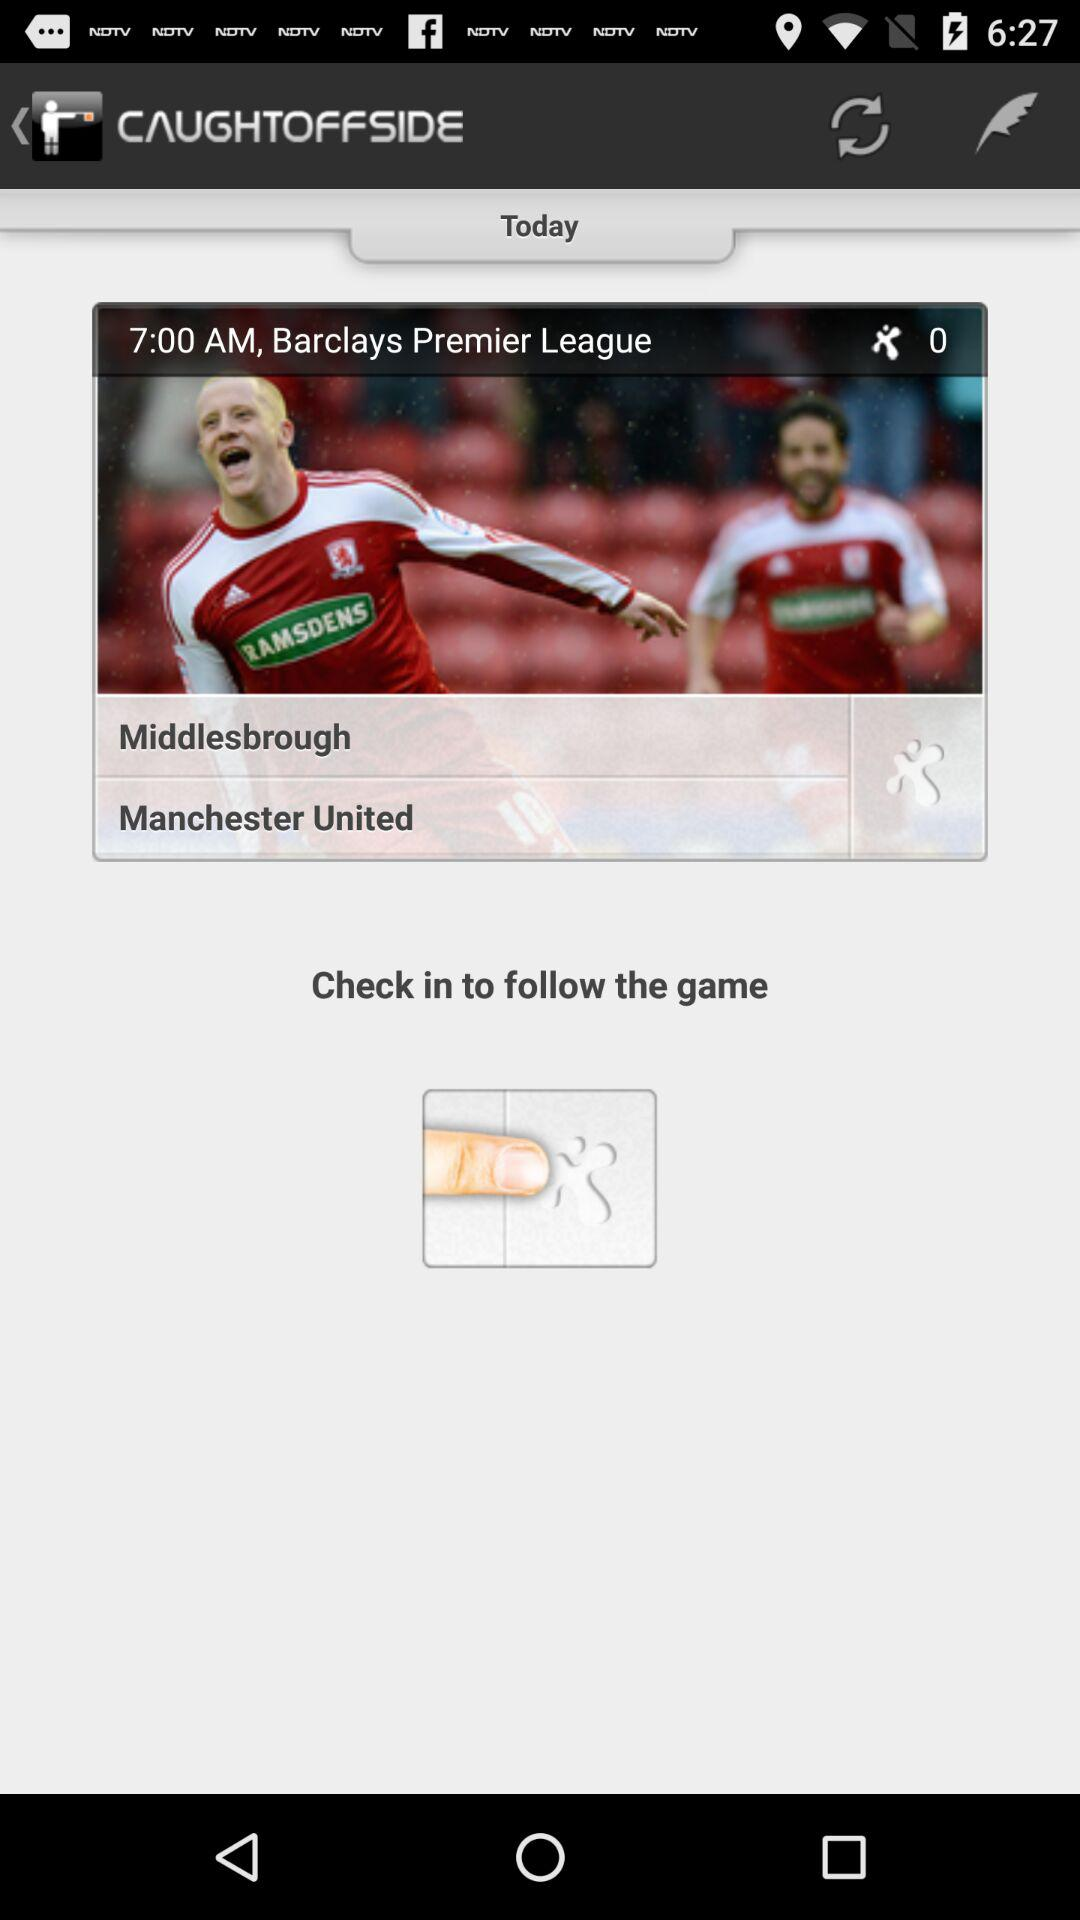What is the time of the "Barclays Premier League"? The time of the "Barclays Premier League" is 7:00 AM. 